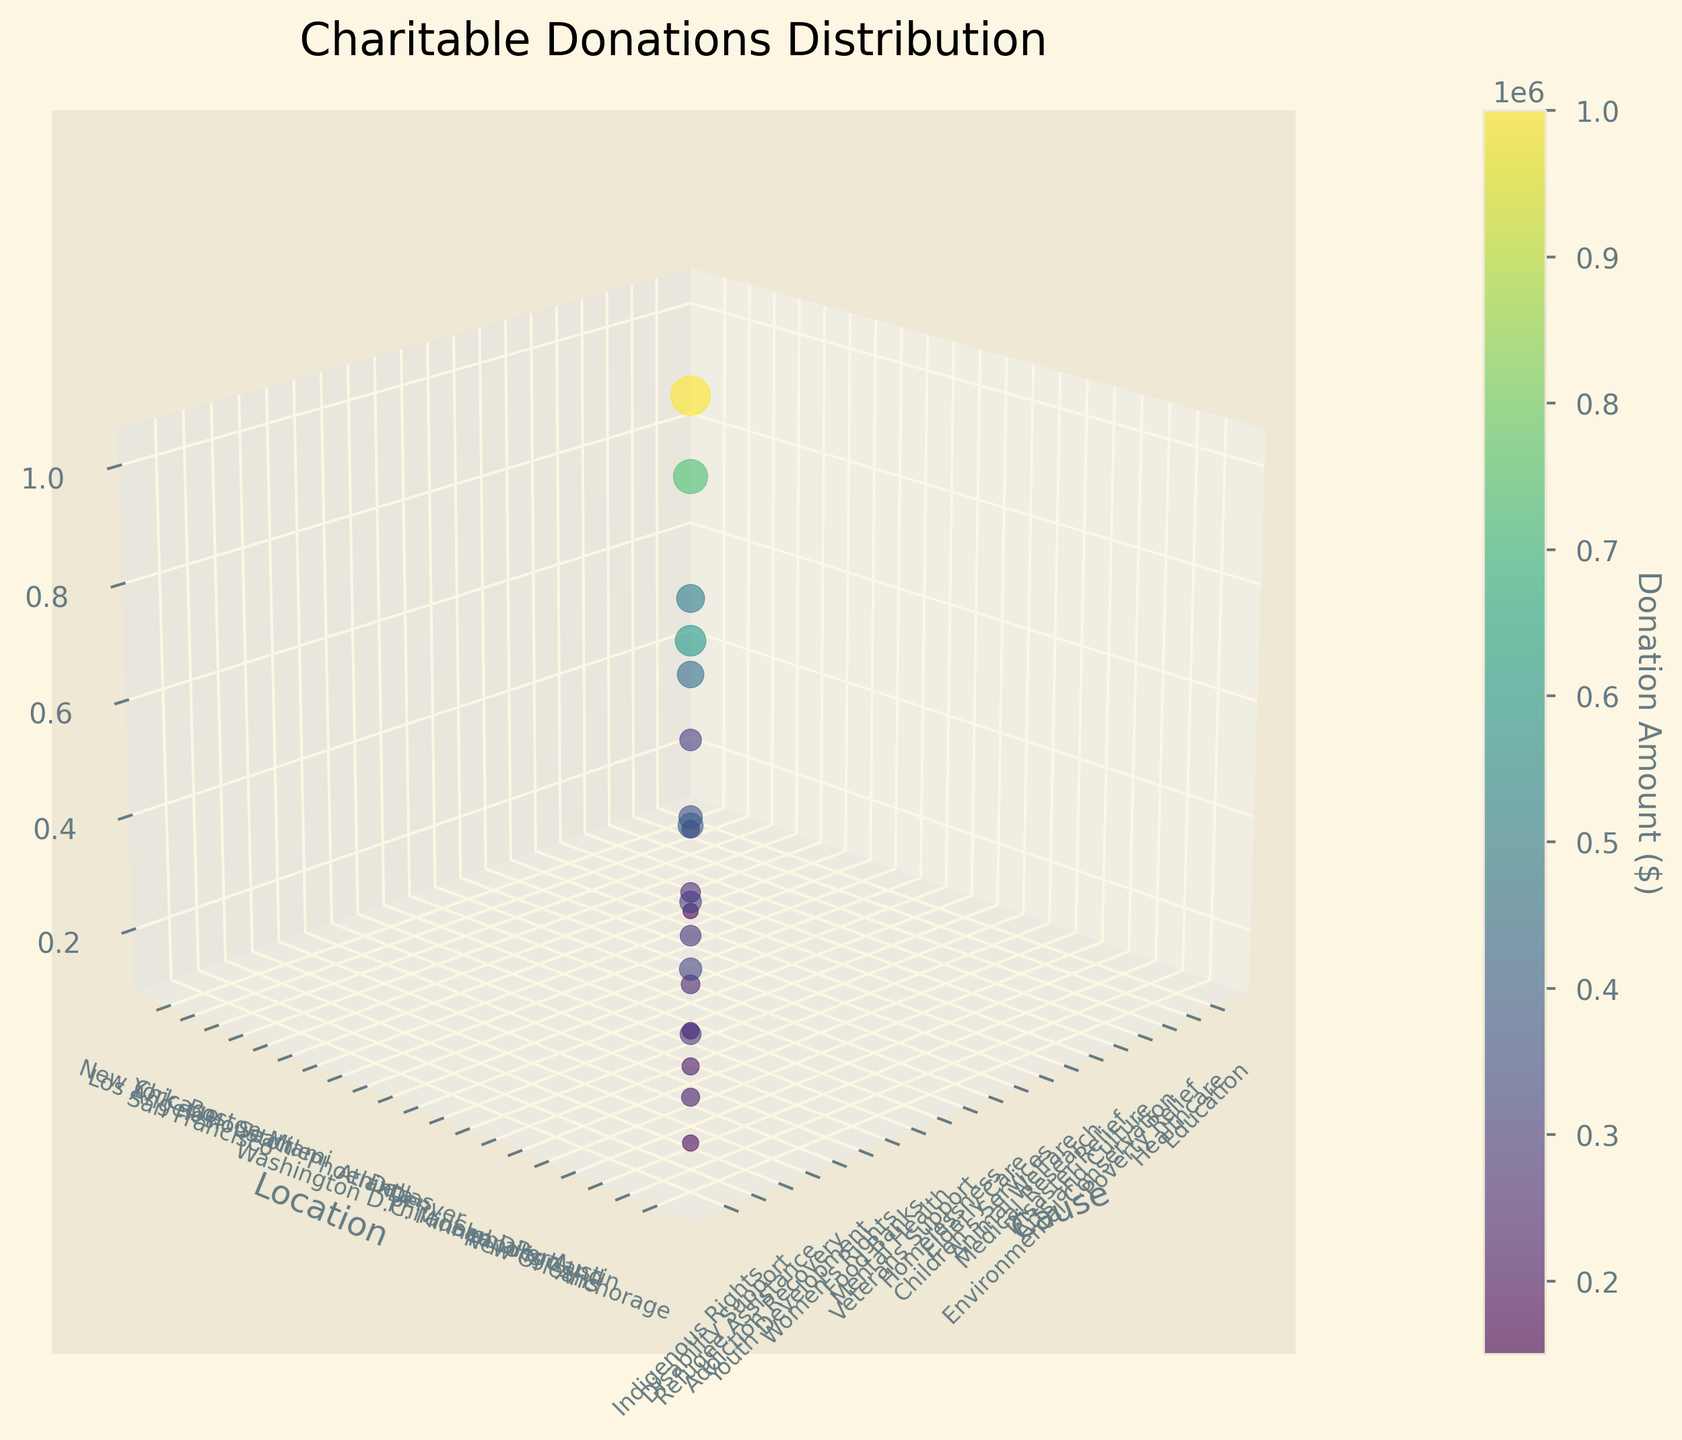what is the title of the figure? The title is prominently shown at the top of the figure, summarizing the focus of the plot, which helps in quickly understanding the main topic being visualized.
Answer: Charitable Donations Distribution What are the labels of the axes? The axes are labeled to clarify what each dimension of the plot represents. The x-axis is labeled 'Cause', the y-axis 'Location', and the z-axis 'Amount ($)', providing context for interpreting the plotted data.
Answer: Cause, Location, Amount ($) Which donation cause has the largest donation amount? By observing the z-axis and comparing the heights of the data points, the donation to 'Disaster Relief' in Houston stands out as the highest, represented by the tallest point on the plot.
Answer: Disaster Relief, Houston Are there more donations towards 'Poverty Relief' or 'Elderly Care'? Comparing the position of these two causes on the z-axis, we can see that the donation for 'Poverty Relief' is $300,000, whereas 'Elderly Care' is $250,000.
Answer: Poverty Relief Which locations have donations over $500,000? By looking at the scatter points that have z-values above $500,000 and identifying their corresponding y-axis labels, we can see that New York, Los Angeles, Houston, and Seattle have donations exceeding this amount.
Answer: New York, Los Angeles, Houston, Seattle What is the total donation amount for 'Healthcare' and 'Mental Health'? First, identify the donation amounts for these causes: 'Healthcare' has $750,000 and 'Mental Health' has $275,000. Then, sum these values: $750,000 + $275,000 = $1,025,000.
Answer: $1,025,000 Which cause received the smallest donation, and in which location? The smallest donation is represented by the point with the lowest z-value. The 'Indigenous Rights' cause in Anchorage received the smallest donation of $170,000.
Answer: Indigenous Rights, Anchorage How are the donation amounts distributed across different causes? The distribution of donation amounts can be seen by examining the scatter points along the z-axis, where amounts range from $170,000 to $1,000,000. Causes with larger bubbles represent higher donations.
Answer: Varied from $170,000 to $1,000,000 Is there a visible pattern or trend in donation amounts based on the geographic location? When assessing the scatter plot, there does not appear to be a straightforward pattern correlating specific geographic locations with larger or smaller donation amounts; donations are widely distributed across various locations.
Answer: No clear pattern What is the average donation amount across all causes? Sum all the donation amounts and divide by the number of causes. The total is $6,750,000 (sum of all amounts in the data), and there are 20 causes, so the average is $6,750,000 / 20 = $337,500.
Answer: $337,500 